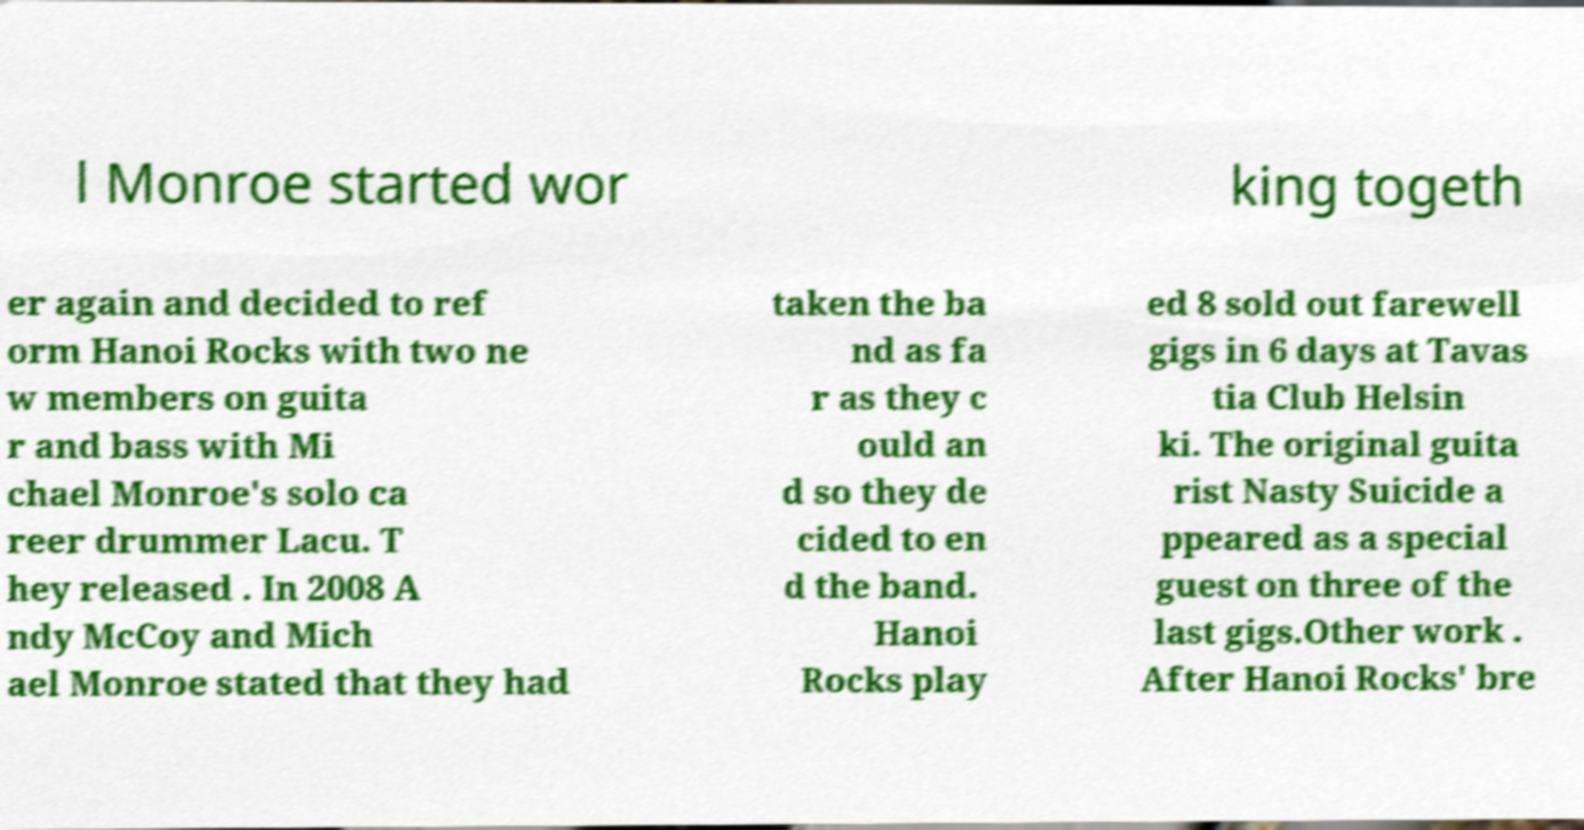Could you extract and type out the text from this image? l Monroe started wor king togeth er again and decided to ref orm Hanoi Rocks with two ne w members on guita r and bass with Mi chael Monroe's solo ca reer drummer Lacu. T hey released . In 2008 A ndy McCoy and Mich ael Monroe stated that they had taken the ba nd as fa r as they c ould an d so they de cided to en d the band. Hanoi Rocks play ed 8 sold out farewell gigs in 6 days at Tavas tia Club Helsin ki. The original guita rist Nasty Suicide a ppeared as a special guest on three of the last gigs.Other work . After Hanoi Rocks' bre 